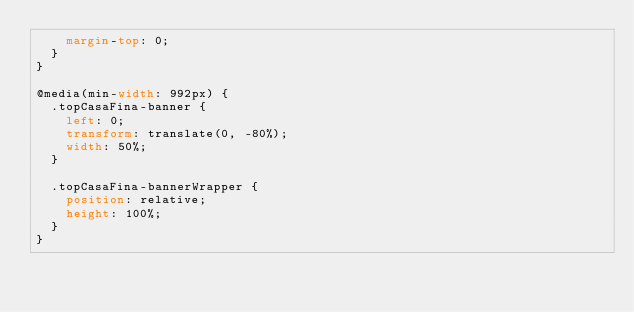Convert code to text. <code><loc_0><loc_0><loc_500><loc_500><_CSS_>		margin-top: 0;	
	}
}

@media(min-width: 992px) {
	.topCasaFina-banner {
		left: 0;
		transform: translate(0, -80%);
		width: 50%;
	}

	.topCasaFina-bannerWrapper {
		position: relative;
		height: 100%;
	}
}


</code> 